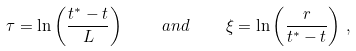<formula> <loc_0><loc_0><loc_500><loc_500>\tau = \ln \left ( \frac { t ^ { * } - t } { L } \right ) \quad a n d \quad \xi = \ln \left ( \frac { r } { t ^ { * } - t } \right ) \, ,</formula> 